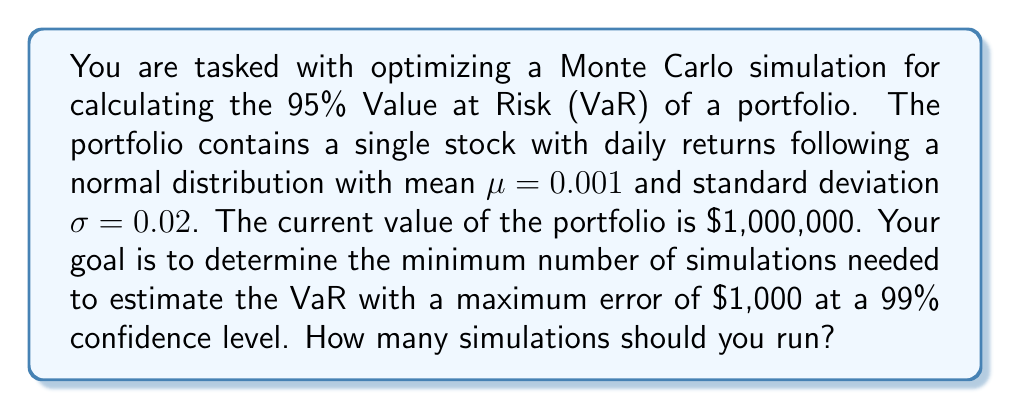Show me your answer to this math problem. To solve this problem, we'll use the Central Limit Theorem and the properties of the normal distribution. Here's a step-by-step approach:

1) The VaR estimation using Monte Carlo simulation follows an approximate normal distribution.

2) The standard error of the VaR estimate is given by:

   $$SE_{VaR} = \frac{\sigma_{VaR}}{\sqrt{n}}$$

   where $\sigma_{VaR}$ is the standard deviation of the VaR estimates and $n$ is the number of simulations.

3) For a 99% confidence level, the maximum error is related to the standard error by:

   $$\text{Max Error} = 2.576 \cdot SE_{VaR}$$

   where 2.576 is the z-score for a 99% confidence level.

4) We can estimate $\sigma_{VaR}$ using the properties of the normal distribution:

   $$\sigma_{VaR} \approx \frac{p(1-p)}{f(z_p)}$$

   where $p = 0.05$ (since we're calculating 95% VaR), and $f(z_p)$ is the probability density function of the standard normal distribution at the p-th quantile.

5) Calculate $z_p$:
   
   $$z_p = \Phi^{-1}(0.05) \approx -1.645$$

6) Calculate $f(z_p)$:

   $$f(z_p) = \frac{1}{\sqrt{2\pi}} e^{-z_p^2/2} \approx 0.103$$

7) Now we can estimate $\sigma_{VaR}$:

   $$\sigma_{VaR} \approx \frac{0.05(1-0.05)}{0.103} \approx 0.461$$

8) Substituting into the error equation:

   $$1000 = 2.576 \cdot \frac{0.461}{\sqrt{n}}$$

9) Solving for $n$:

   $$n = \left(\frac{2.576 \cdot 0.461}{1000}\right)^2 \cdot 1,000,000^2 \approx 1,414$$

10) Since we need an integer number of simulations, we round up to ensure we meet the maximum error requirement.
Answer: 1,415 simulations 